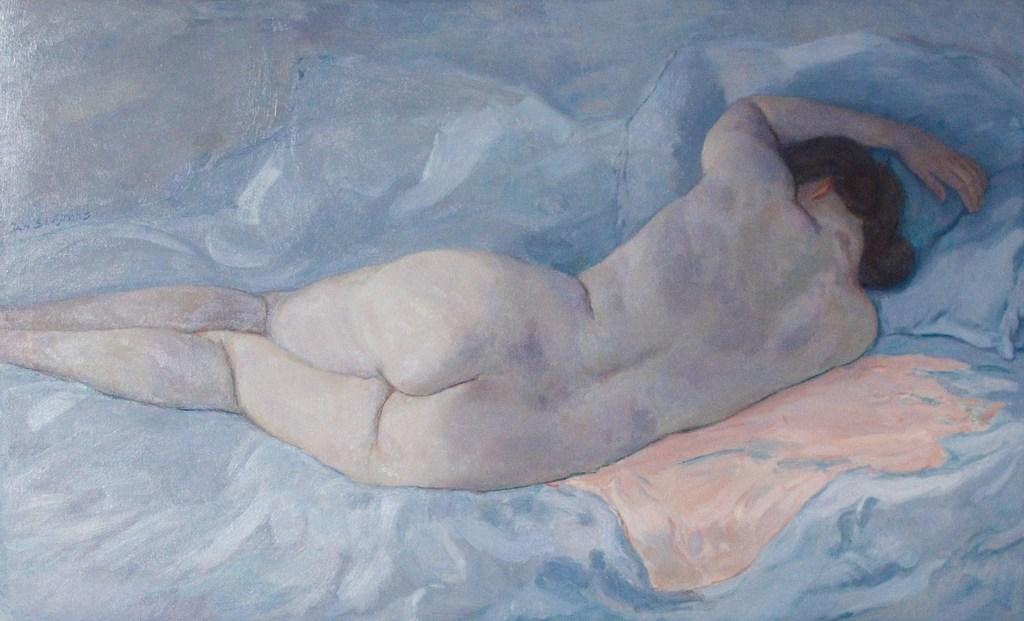How would you summarize this image in a sentence or two? In this picture there is a painting in the center of the image. 